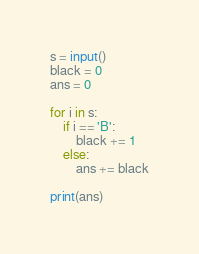Convert code to text. <code><loc_0><loc_0><loc_500><loc_500><_Python_>s = input()
black = 0
ans = 0

for i in s:
    if i == 'B':
        black += 1
    else:
        ans += black

print(ans)
</code> 